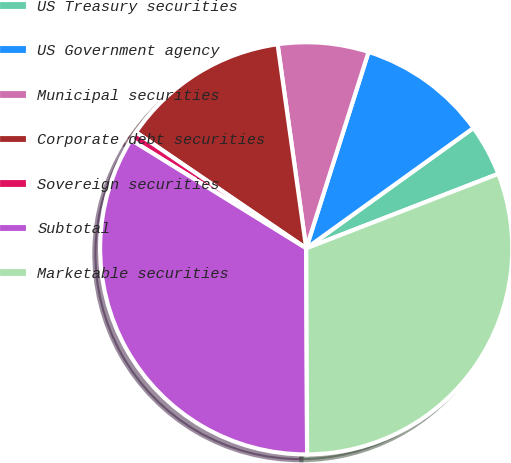Convert chart. <chart><loc_0><loc_0><loc_500><loc_500><pie_chart><fcel>US Treasury securities<fcel>US Government agency<fcel>Municipal securities<fcel>Corporate debt securities<fcel>Sovereign securities<fcel>Subtotal<fcel>Marketable securities<nl><fcel>4.04%<fcel>10.18%<fcel>7.11%<fcel>13.26%<fcel>0.7%<fcel>33.89%<fcel>30.82%<nl></chart> 